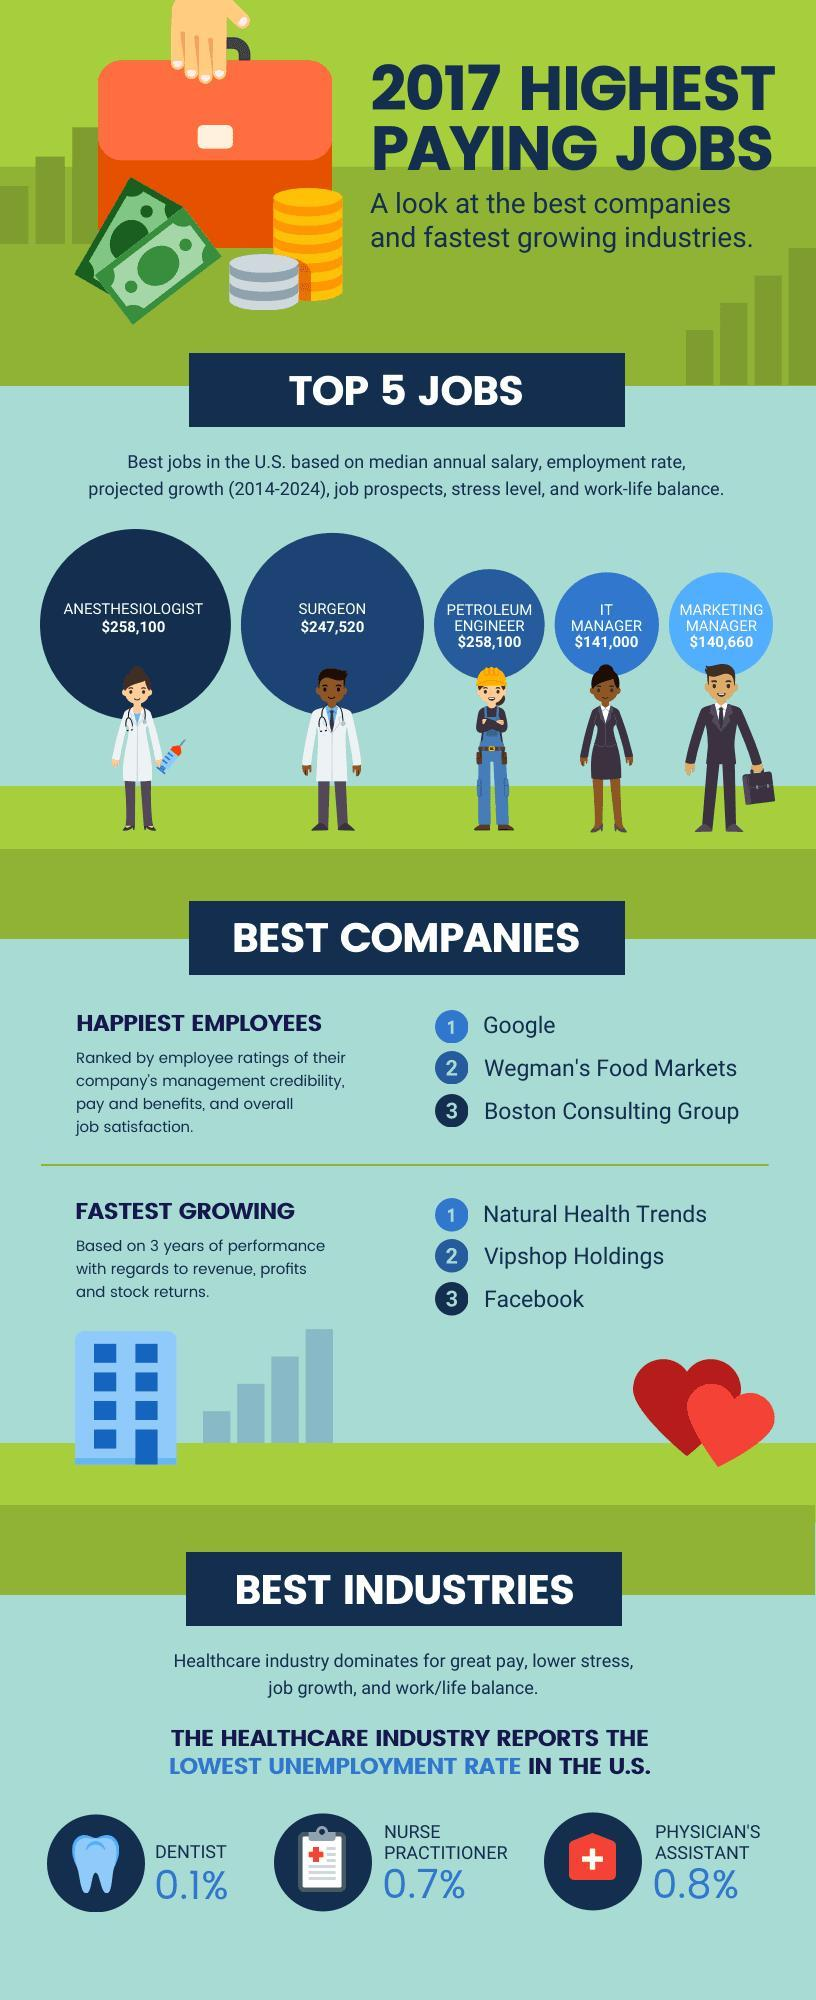Who draws a higher salary - Surgeon or  Anesthesiologist?
Answer the question with a short phrase. Anesthesiologist In the image, Facebook is listed third in which category of companies? Fastest growing What is the median annual salary of a surgeon in US? $247,520 A Petroleum engineer draws a salary amount same as which other professional? Anesthesiologist Boston Consulting Group is listed third in which category of companies? Happiest Employees In the shown figure, who draws a salary lower than that of an IT Manager? Marketing Manager What is the median annual salary of the fourth job listed among the top 5 jobs in US? $141,000 What is third among the top jobs in US? Petroleum Engineer Who draws a salary of $247,520? surgeon What is the rate of unemployment among dentists in US? 0.1% 